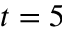<formula> <loc_0><loc_0><loc_500><loc_500>t = 5</formula> 